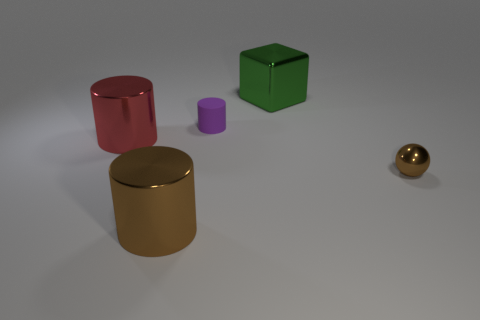What number of other objects are the same shape as the tiny purple thing?
Offer a very short reply. 2. Is the object that is in front of the ball made of the same material as the big cylinder that is on the left side of the brown cylinder?
Give a very brief answer. Yes. What is the shape of the shiny object that is in front of the red metallic thing and to the left of the small brown sphere?
Provide a short and direct response. Cylinder. Are there any other things that have the same material as the purple cylinder?
Offer a terse response. No. The object that is both to the right of the tiny cylinder and behind the small sphere is made of what material?
Provide a succinct answer. Metal. There is a big brown thing that is made of the same material as the block; what is its shape?
Your answer should be very brief. Cylinder. Is there any other thing that is the same color as the rubber cylinder?
Ensure brevity in your answer.  No. Are there more objects that are to the left of the big green metallic cube than tiny yellow cylinders?
Offer a terse response. Yes. What material is the block?
Offer a very short reply. Metal. How many rubber cylinders have the same size as the sphere?
Offer a very short reply. 1. 